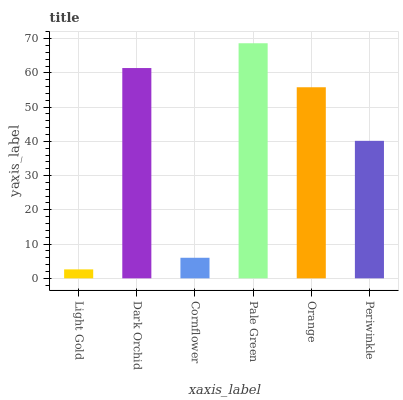Is Light Gold the minimum?
Answer yes or no. Yes. Is Pale Green the maximum?
Answer yes or no. Yes. Is Dark Orchid the minimum?
Answer yes or no. No. Is Dark Orchid the maximum?
Answer yes or no. No. Is Dark Orchid greater than Light Gold?
Answer yes or no. Yes. Is Light Gold less than Dark Orchid?
Answer yes or no. Yes. Is Light Gold greater than Dark Orchid?
Answer yes or no. No. Is Dark Orchid less than Light Gold?
Answer yes or no. No. Is Orange the high median?
Answer yes or no. Yes. Is Periwinkle the low median?
Answer yes or no. Yes. Is Light Gold the high median?
Answer yes or no. No. Is Cornflower the low median?
Answer yes or no. No. 